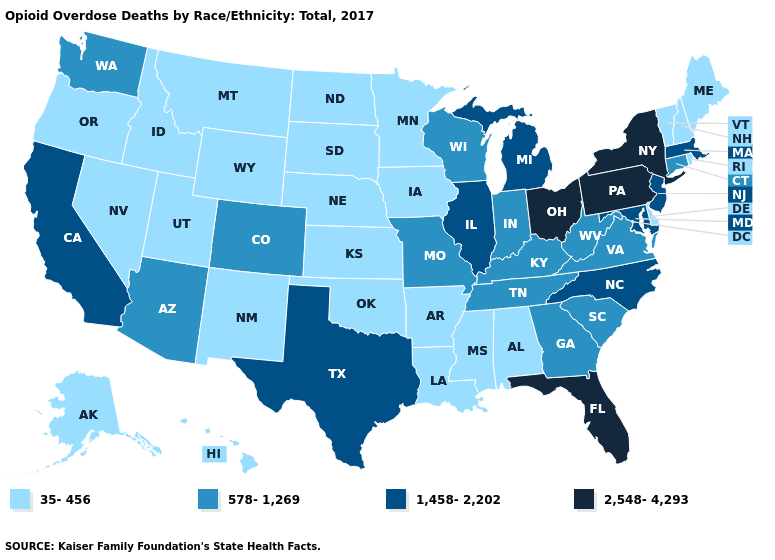What is the value of Indiana?
Concise answer only. 578-1,269. What is the value of Indiana?
Quick response, please. 578-1,269. Is the legend a continuous bar?
Answer briefly. No. Does West Virginia have the lowest value in the USA?
Keep it brief. No. What is the value of Connecticut?
Write a very short answer. 578-1,269. Does Florida have the same value as New York?
Short answer required. Yes. Does the map have missing data?
Quick response, please. No. Does the map have missing data?
Be succinct. No. Does Connecticut have a higher value than Georgia?
Short answer required. No. Name the states that have a value in the range 35-456?
Keep it brief. Alabama, Alaska, Arkansas, Delaware, Hawaii, Idaho, Iowa, Kansas, Louisiana, Maine, Minnesota, Mississippi, Montana, Nebraska, Nevada, New Hampshire, New Mexico, North Dakota, Oklahoma, Oregon, Rhode Island, South Dakota, Utah, Vermont, Wyoming. What is the highest value in the Northeast ?
Quick response, please. 2,548-4,293. What is the value of Arkansas?
Concise answer only. 35-456. Among the states that border Alabama , which have the highest value?
Short answer required. Florida. Which states hav the highest value in the South?
Give a very brief answer. Florida. Name the states that have a value in the range 578-1,269?
Be succinct. Arizona, Colorado, Connecticut, Georgia, Indiana, Kentucky, Missouri, South Carolina, Tennessee, Virginia, Washington, West Virginia, Wisconsin. 